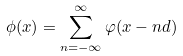Convert formula to latex. <formula><loc_0><loc_0><loc_500><loc_500>\phi ( x ) = \sum _ { n = - \infty } ^ { \infty } \varphi ( x - n d )</formula> 